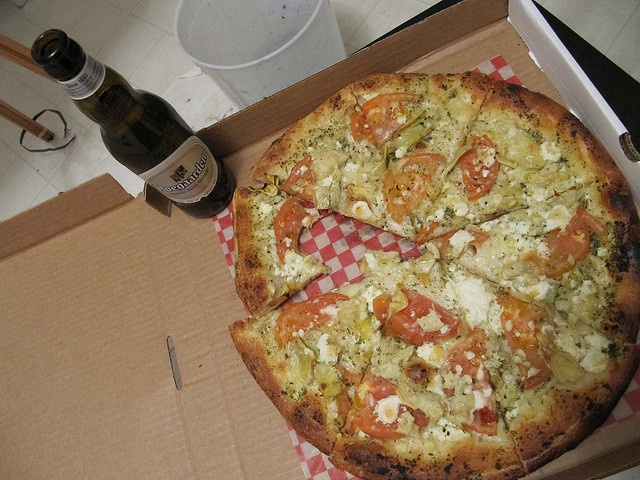Describe the objects in this image and their specific colors. I can see pizza in black, tan, brown, olive, and maroon tones, dining table in black, darkgray, and gray tones, bottle in black and gray tones, and cup in black and gray tones in this image. 